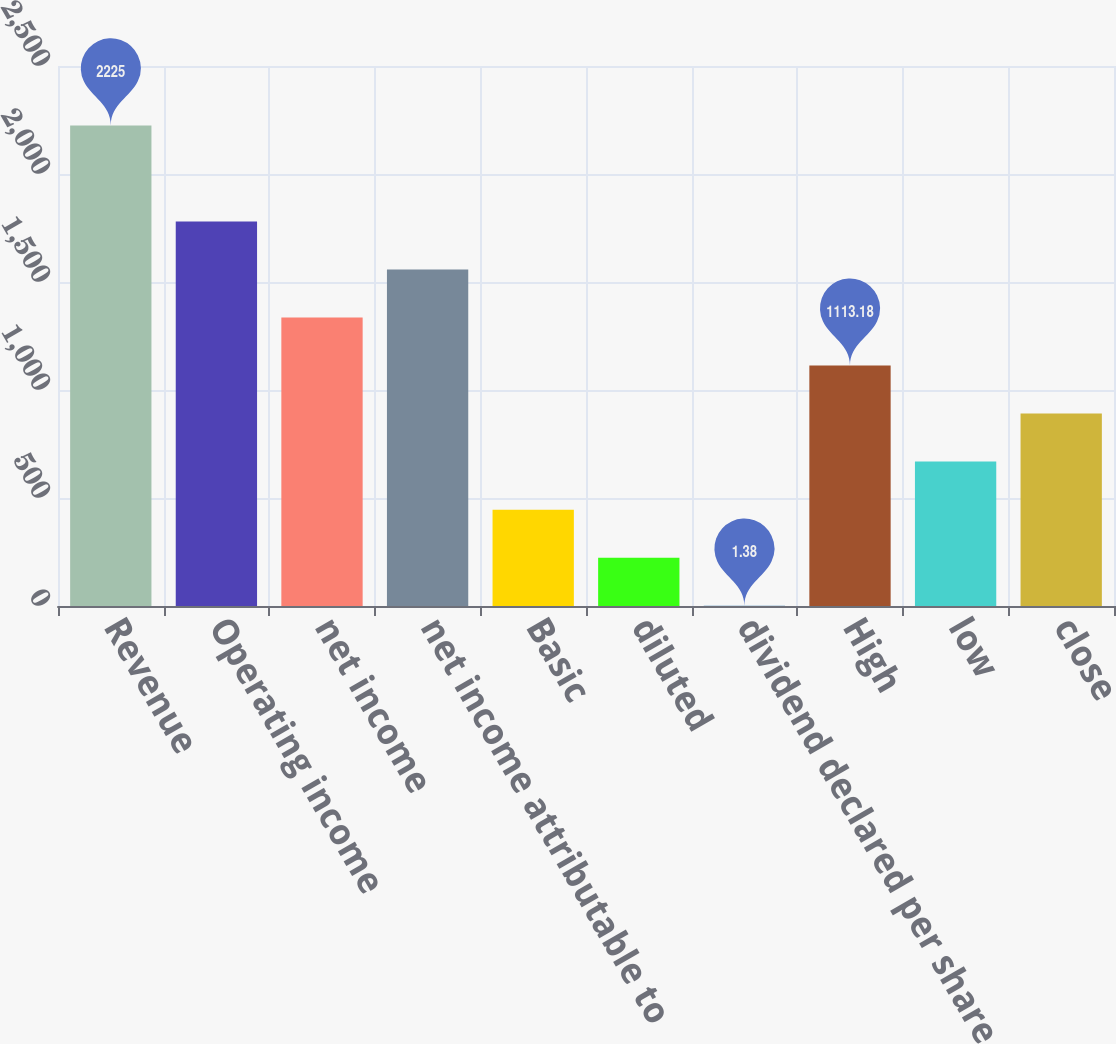Convert chart to OTSL. <chart><loc_0><loc_0><loc_500><loc_500><bar_chart><fcel>Revenue<fcel>Operating income<fcel>net income<fcel>net income attributable to<fcel>Basic<fcel>diluted<fcel>dividend declared per share<fcel>High<fcel>low<fcel>close<nl><fcel>2225<fcel>1780.26<fcel>1335.54<fcel>1557.9<fcel>446.1<fcel>223.74<fcel>1.38<fcel>1113.18<fcel>668.46<fcel>890.82<nl></chart> 